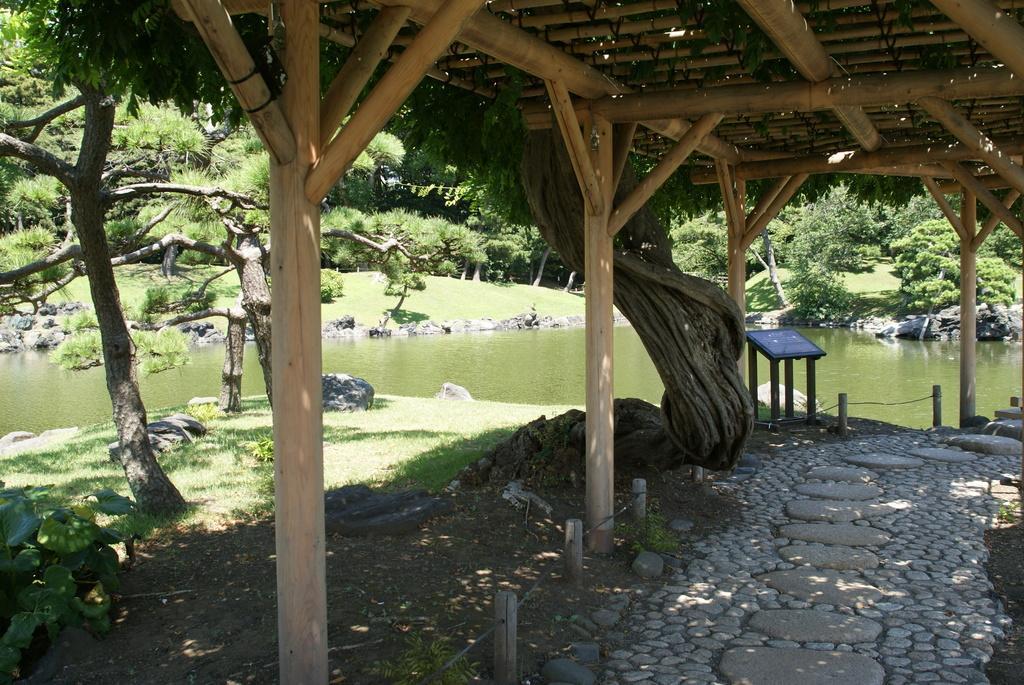Can you describe this image briefly? In this image in the foreground there is a shelter. in the background there are trees, stones, water body. Here there is a table. 